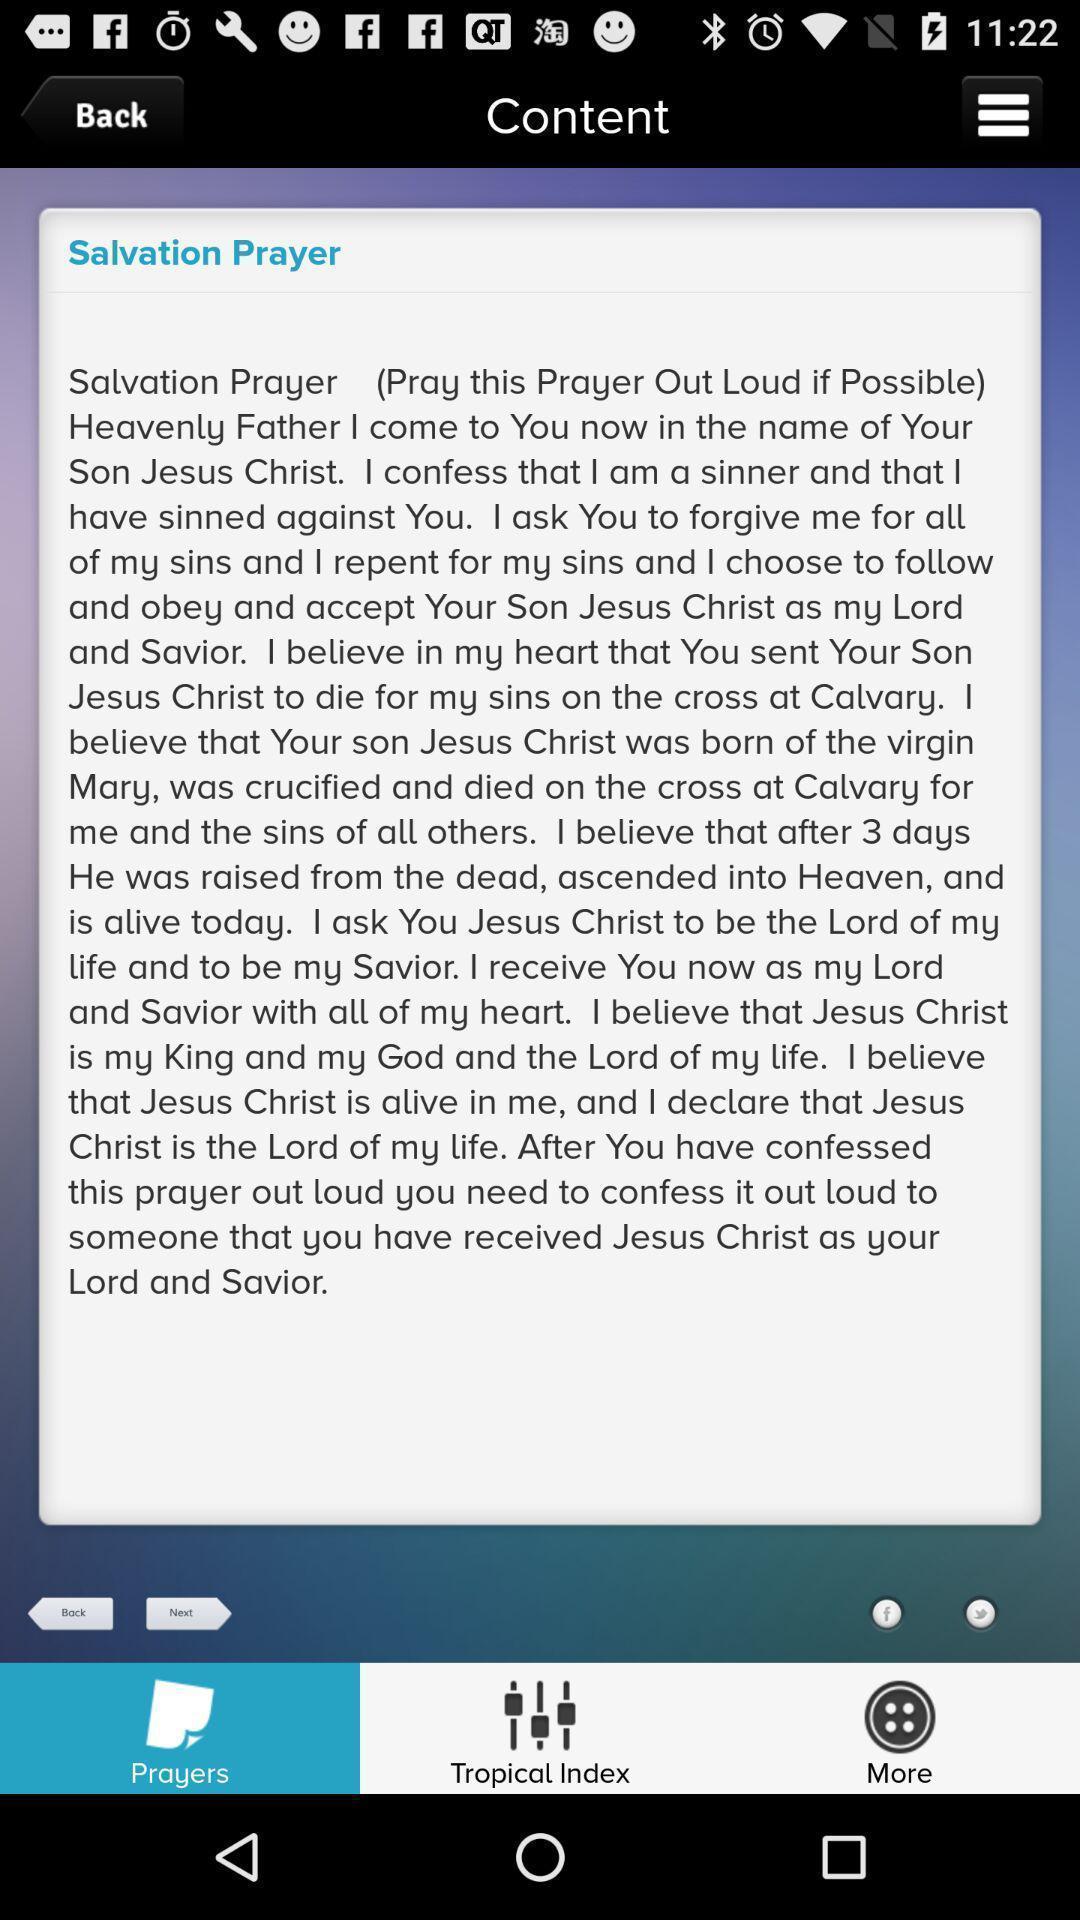Tell me about the visual elements in this screen capture. Page showing the content of a topic. 